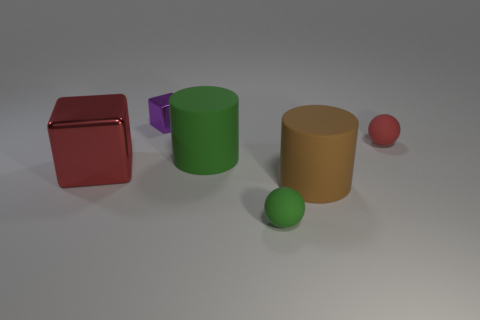Add 1 tiny matte things. How many objects exist? 7 Subtract all cubes. How many objects are left? 4 Subtract 0 brown cubes. How many objects are left? 6 Subtract all large blocks. Subtract all big cylinders. How many objects are left? 3 Add 6 small green matte balls. How many small green matte balls are left? 7 Add 4 gray metallic cubes. How many gray metallic cubes exist? 4 